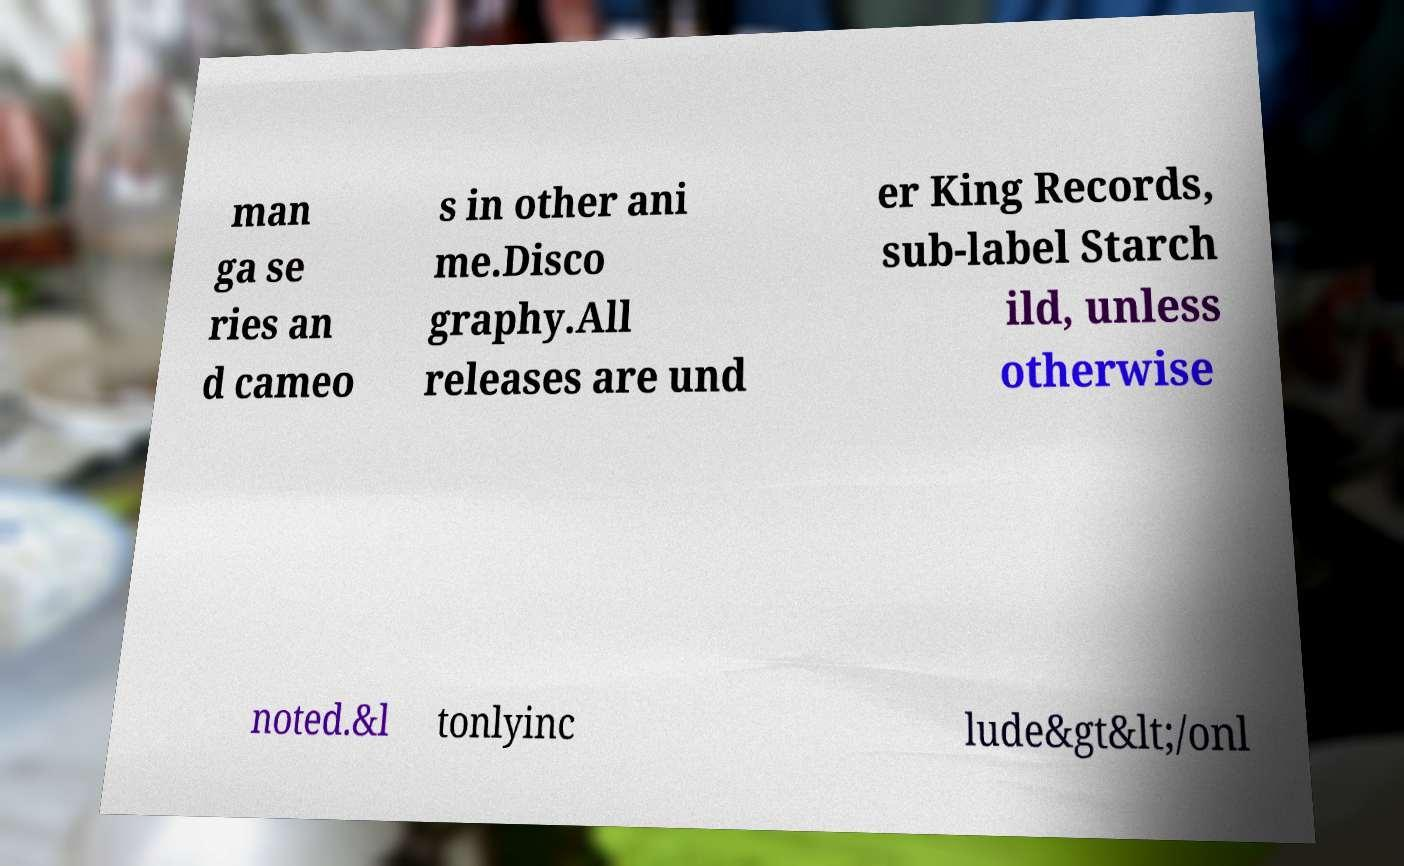There's text embedded in this image that I need extracted. Can you transcribe it verbatim? man ga se ries an d cameo s in other ani me.Disco graphy.All releases are und er King Records, sub-label Starch ild, unless otherwise noted.&l tonlyinc lude&gt&lt;/onl 